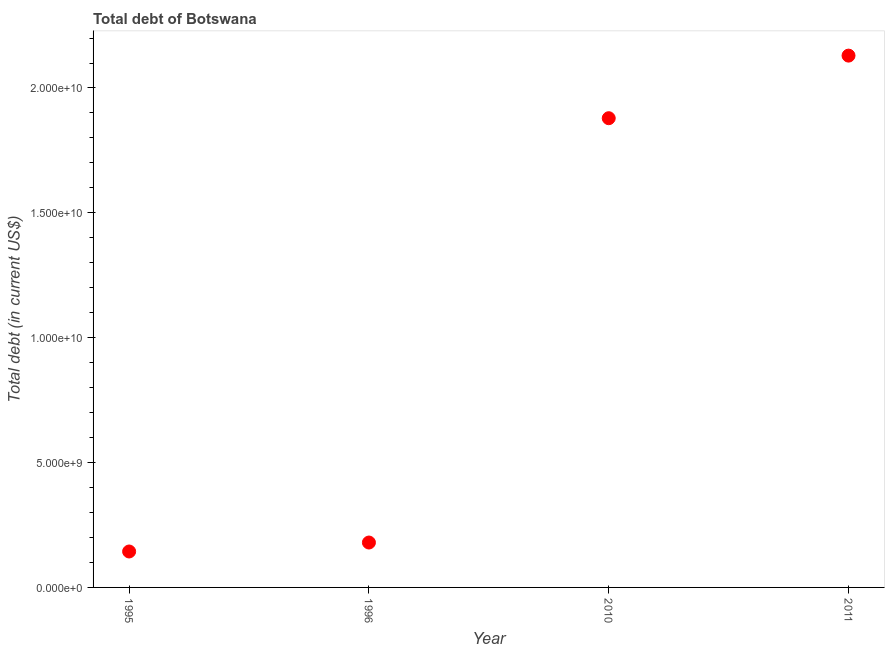What is the total debt in 1995?
Make the answer very short. 1.44e+09. Across all years, what is the maximum total debt?
Offer a very short reply. 2.13e+1. Across all years, what is the minimum total debt?
Offer a terse response. 1.44e+09. In which year was the total debt minimum?
Offer a terse response. 1995. What is the sum of the total debt?
Make the answer very short. 4.33e+1. What is the difference between the total debt in 1996 and 2011?
Your answer should be very brief. -1.95e+1. What is the average total debt per year?
Give a very brief answer. 1.08e+1. What is the median total debt?
Ensure brevity in your answer.  1.03e+1. In how many years, is the total debt greater than 1000000000 US$?
Provide a succinct answer. 4. Do a majority of the years between 1996 and 1995 (inclusive) have total debt greater than 1000000000 US$?
Ensure brevity in your answer.  No. What is the ratio of the total debt in 1996 to that in 2011?
Your response must be concise. 0.08. What is the difference between the highest and the second highest total debt?
Keep it short and to the point. 2.51e+09. Is the sum of the total debt in 1995 and 2011 greater than the maximum total debt across all years?
Your answer should be compact. Yes. What is the difference between the highest and the lowest total debt?
Give a very brief answer. 1.99e+1. In how many years, is the total debt greater than the average total debt taken over all years?
Make the answer very short. 2. Does the total debt monotonically increase over the years?
Ensure brevity in your answer.  Yes. How many years are there in the graph?
Provide a succinct answer. 4. What is the difference between two consecutive major ticks on the Y-axis?
Provide a succinct answer. 5.00e+09. Does the graph contain any zero values?
Provide a short and direct response. No. What is the title of the graph?
Provide a succinct answer. Total debt of Botswana. What is the label or title of the X-axis?
Your answer should be compact. Year. What is the label or title of the Y-axis?
Ensure brevity in your answer.  Total debt (in current US$). What is the Total debt (in current US$) in 1995?
Your answer should be very brief. 1.44e+09. What is the Total debt (in current US$) in 1996?
Offer a terse response. 1.80e+09. What is the Total debt (in current US$) in 2010?
Offer a very short reply. 1.88e+1. What is the Total debt (in current US$) in 2011?
Make the answer very short. 2.13e+1. What is the difference between the Total debt (in current US$) in 1995 and 1996?
Your answer should be compact. -3.59e+08. What is the difference between the Total debt (in current US$) in 1995 and 2010?
Provide a short and direct response. -1.74e+1. What is the difference between the Total debt (in current US$) in 1995 and 2011?
Ensure brevity in your answer.  -1.99e+1. What is the difference between the Total debt (in current US$) in 1996 and 2010?
Your response must be concise. -1.70e+1. What is the difference between the Total debt (in current US$) in 1996 and 2011?
Your answer should be compact. -1.95e+1. What is the difference between the Total debt (in current US$) in 2010 and 2011?
Offer a terse response. -2.51e+09. What is the ratio of the Total debt (in current US$) in 1995 to that in 2010?
Your answer should be compact. 0.08. What is the ratio of the Total debt (in current US$) in 1995 to that in 2011?
Provide a short and direct response. 0.07. What is the ratio of the Total debt (in current US$) in 1996 to that in 2010?
Your answer should be very brief. 0.1. What is the ratio of the Total debt (in current US$) in 1996 to that in 2011?
Provide a succinct answer. 0.08. What is the ratio of the Total debt (in current US$) in 2010 to that in 2011?
Make the answer very short. 0.88. 